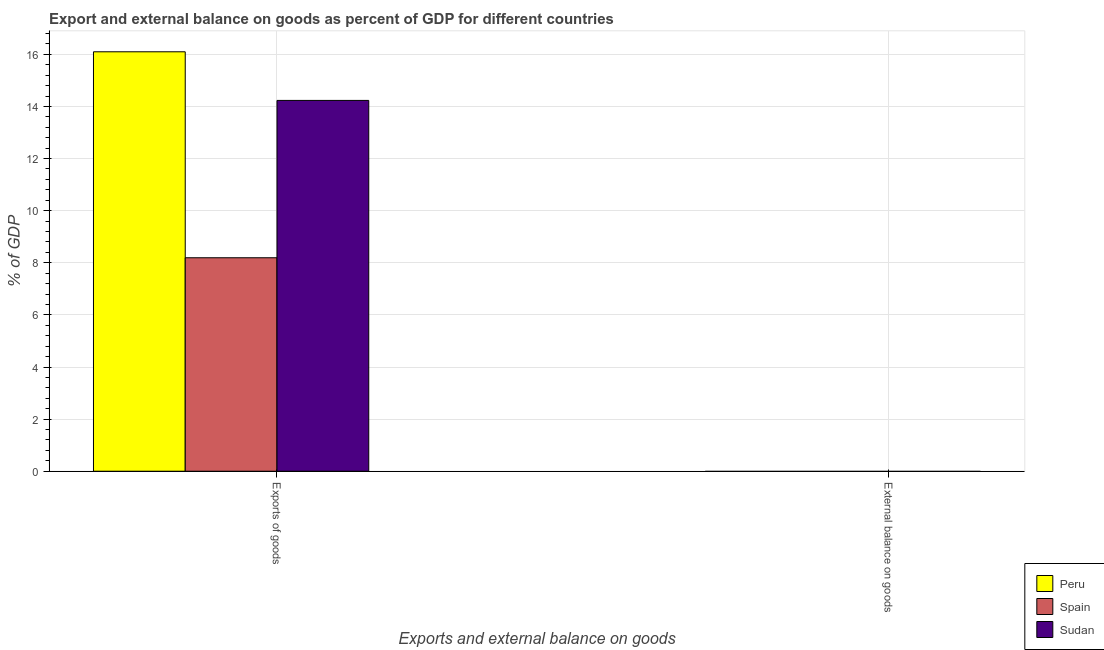What is the label of the 2nd group of bars from the left?
Offer a very short reply. External balance on goods. Across all countries, what is the maximum export of goods as percentage of gdp?
Offer a terse response. 16.1. Across all countries, what is the minimum external balance on goods as percentage of gdp?
Make the answer very short. 0. What is the total export of goods as percentage of gdp in the graph?
Offer a terse response. 38.52. What is the difference between the export of goods as percentage of gdp in Spain and that in Sudan?
Your answer should be compact. -6.04. What is the difference between the external balance on goods as percentage of gdp in Sudan and the export of goods as percentage of gdp in Spain?
Give a very brief answer. -8.19. What is the average export of goods as percentage of gdp per country?
Your answer should be very brief. 12.84. What is the ratio of the export of goods as percentage of gdp in Sudan to that in Peru?
Provide a succinct answer. 0.88. Are all the bars in the graph horizontal?
Offer a terse response. No. How many countries are there in the graph?
Offer a very short reply. 3. What is the difference between two consecutive major ticks on the Y-axis?
Keep it short and to the point. 2. How many legend labels are there?
Make the answer very short. 3. How are the legend labels stacked?
Your response must be concise. Vertical. What is the title of the graph?
Keep it short and to the point. Export and external balance on goods as percent of GDP for different countries. Does "Macedonia" appear as one of the legend labels in the graph?
Make the answer very short. No. What is the label or title of the X-axis?
Give a very brief answer. Exports and external balance on goods. What is the label or title of the Y-axis?
Your answer should be compact. % of GDP. What is the % of GDP in Peru in Exports of goods?
Make the answer very short. 16.1. What is the % of GDP of Spain in Exports of goods?
Ensure brevity in your answer.  8.19. What is the % of GDP in Sudan in Exports of goods?
Ensure brevity in your answer.  14.23. Across all Exports and external balance on goods, what is the maximum % of GDP in Peru?
Provide a short and direct response. 16.1. Across all Exports and external balance on goods, what is the maximum % of GDP of Spain?
Your answer should be very brief. 8.19. Across all Exports and external balance on goods, what is the maximum % of GDP of Sudan?
Give a very brief answer. 14.23. Across all Exports and external balance on goods, what is the minimum % of GDP in Peru?
Your answer should be compact. 0. Across all Exports and external balance on goods, what is the minimum % of GDP in Spain?
Your response must be concise. 0. Across all Exports and external balance on goods, what is the minimum % of GDP in Sudan?
Ensure brevity in your answer.  0. What is the total % of GDP of Peru in the graph?
Offer a very short reply. 16.1. What is the total % of GDP in Spain in the graph?
Give a very brief answer. 8.19. What is the total % of GDP of Sudan in the graph?
Offer a terse response. 14.23. What is the average % of GDP in Peru per Exports and external balance on goods?
Offer a very short reply. 8.05. What is the average % of GDP of Spain per Exports and external balance on goods?
Offer a very short reply. 4.1. What is the average % of GDP of Sudan per Exports and external balance on goods?
Offer a terse response. 7.12. What is the difference between the % of GDP in Peru and % of GDP in Spain in Exports of goods?
Your answer should be compact. 7.9. What is the difference between the % of GDP in Peru and % of GDP in Sudan in Exports of goods?
Keep it short and to the point. 1.87. What is the difference between the % of GDP of Spain and % of GDP of Sudan in Exports of goods?
Your response must be concise. -6.04. What is the difference between the highest and the lowest % of GDP in Peru?
Ensure brevity in your answer.  16.1. What is the difference between the highest and the lowest % of GDP of Spain?
Ensure brevity in your answer.  8.19. What is the difference between the highest and the lowest % of GDP in Sudan?
Your response must be concise. 14.23. 